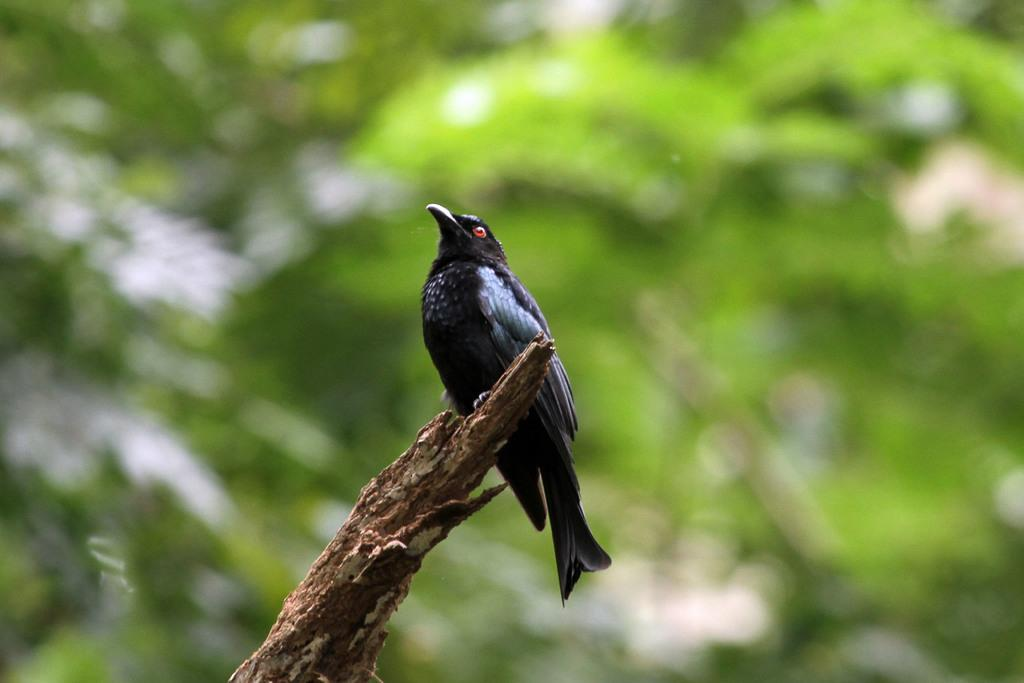What type of animal can be seen in the image? There is a bird in the image. Where is the bird located? The bird is on a branch. Can you describe the background of the image? The background of the image is blurred. What type of finger can be seen in the image? There is no finger present in the image; it features a bird on a branch with a blurred background. 